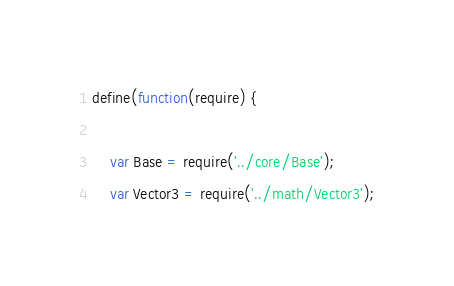<code> <loc_0><loc_0><loc_500><loc_500><_JavaScript_>define(function(require) {

    var Base = require('../core/Base');
    var Vector3 = require('../math/Vector3');</code> 